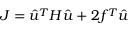Convert formula to latex. <formula><loc_0><loc_0><loc_500><loc_500>J = \hat { u } ^ { T } H \hat { u } + 2 f ^ { T } \hat { u }</formula> 